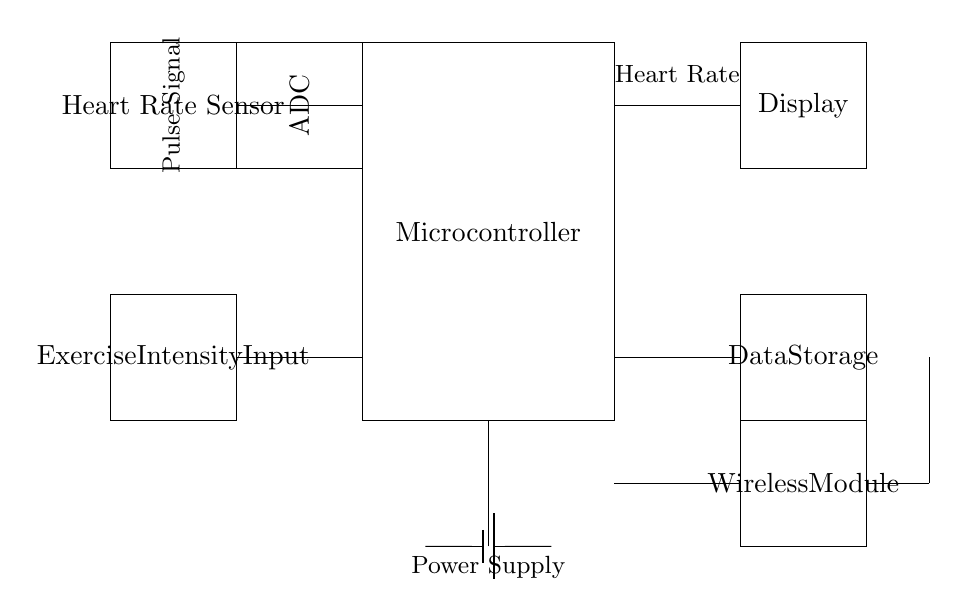What components are present in this circuit? The components in the circuit include a Microcontroller, Heart Rate Sensor, ADC (Analog-to-Digital Converter), Display, Battery, Exercise Intensity Input, Data Storage, Wireless Module, and Antenna.
Answer: Microcontroller, Heart Rate Sensor, ADC, Display, Battery, Exercise Intensity Input, Data Storage, Wireless Module, Antenna What does the Heart Rate Sensor output? The Heart Rate Sensor outputs a pulse signal which is fed to the ADC for conversion. This signal is essential for calculating the heart rate.
Answer: Pulse Signal Which component stores data in the system? The Data Storage component is specifically designated for storing the data collected by the heart rate monitoring system, including heart rate and exercise intensity data.
Answer: Data Storage How is the power supplied to the circuit? Power is supplied through the Battery, which provides the necessary voltage and current to the entire system, as indicated by the battery symbol connected in the circuit diagram.
Answer: Battery What component does the ADC connect to? The ADC connects to both the Heart Rate Sensor and the Microcontroller, processing the pulse signal from the sensor and sending the data to the Microcontroller for further analysis.
Answer: Microcontroller What is the purpose of the Wireless Module? The Wireless Module is used for transmitting the collected data wirelessly, allowing for real-time monitoring of heart rate and exercise intensity during workouts.
Answer: Transmitting data What is the role of the Exercise Intensity Input? The Exercise Intensity Input allows users to input their exercise intensity, which can be used for more personalized heart rate analysis and recommendations based on their activity level.
Answer: Inputting exercise intensity 